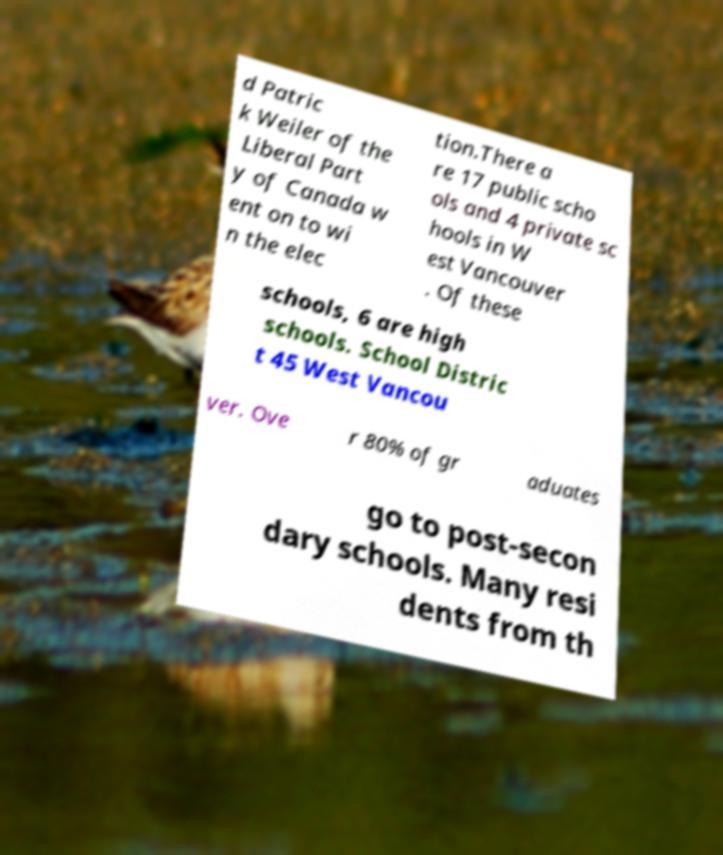Could you assist in decoding the text presented in this image and type it out clearly? d Patric k Weiler of the Liberal Part y of Canada w ent on to wi n the elec tion.There a re 17 public scho ols and 4 private sc hools in W est Vancouver . Of these schools, 6 are high schools. School Distric t 45 West Vancou ver. Ove r 80% of gr aduates go to post-secon dary schools. Many resi dents from th 